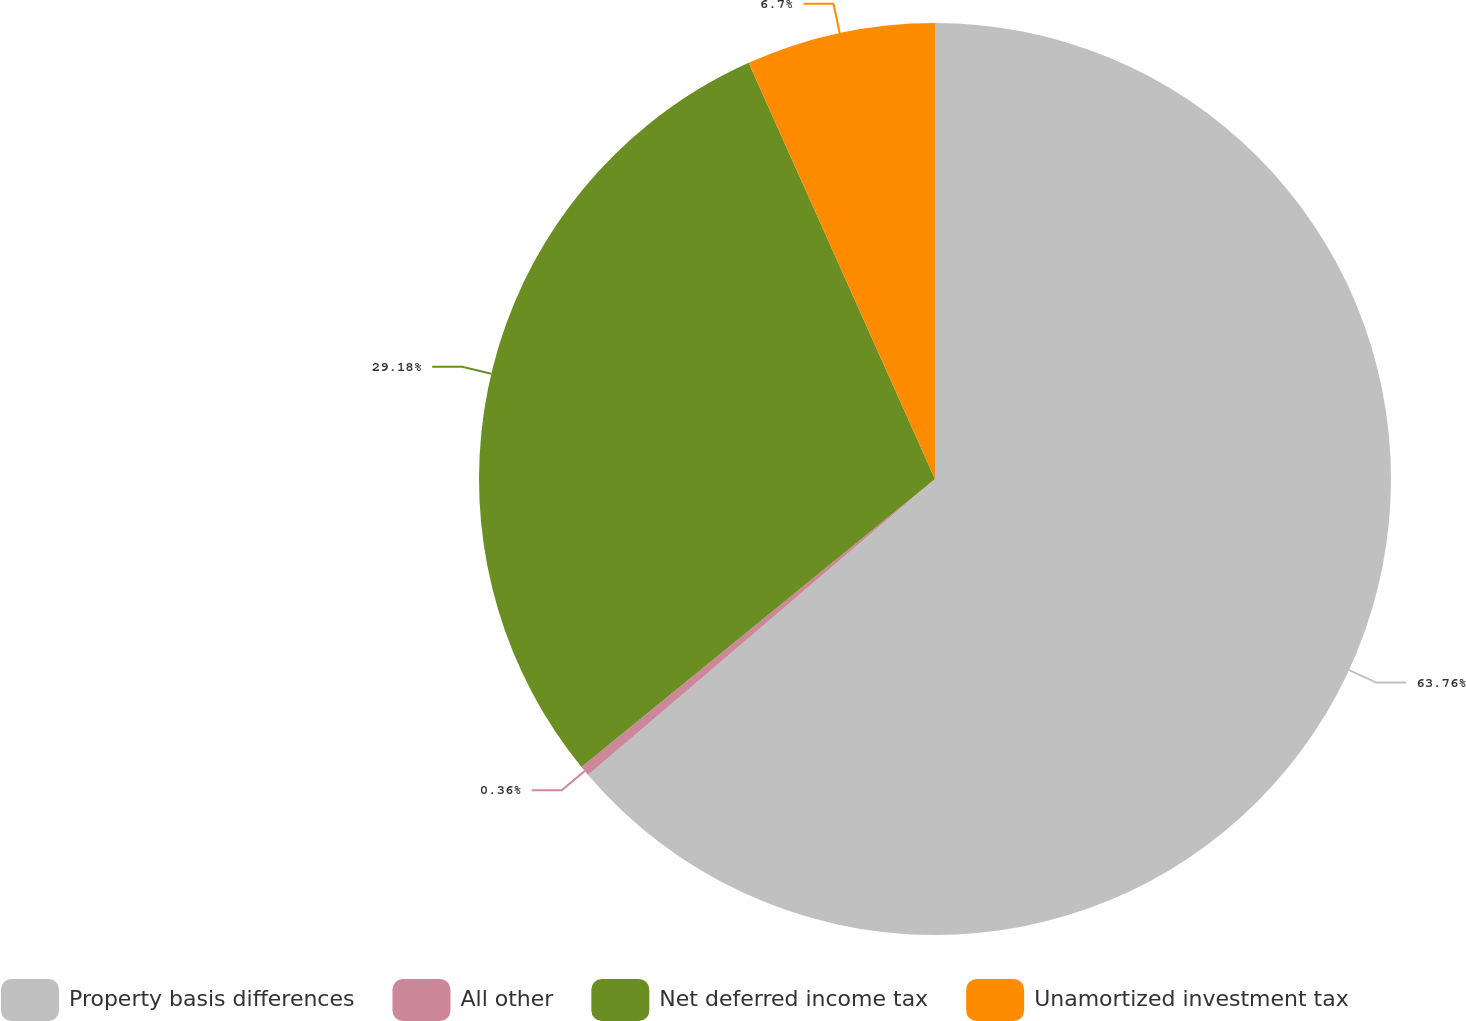Convert chart to OTSL. <chart><loc_0><loc_0><loc_500><loc_500><pie_chart><fcel>Property basis differences<fcel>All other<fcel>Net deferred income tax<fcel>Unamortized investment tax<nl><fcel>63.76%<fcel>0.36%<fcel>29.18%<fcel>6.7%<nl></chart> 